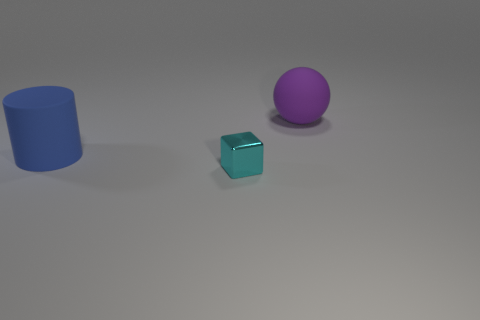Are there any other tiny objects that have the same shape as the blue object?
Offer a terse response. No. There is a blue thing that is the same size as the purple thing; what is its shape?
Keep it short and to the point. Cylinder. There is a big rubber object that is on the left side of the purple thing; what shape is it?
Offer a very short reply. Cylinder. Are there fewer big matte cylinders that are to the right of the blue cylinder than blue things that are behind the large purple rubber ball?
Offer a terse response. No. Does the purple ball have the same size as the object in front of the large blue object?
Your response must be concise. No. What number of matte things have the same size as the rubber ball?
Your response must be concise. 1. What is the color of the cylinder that is the same material as the large sphere?
Make the answer very short. Blue. Is the number of cyan metallic objects greater than the number of tiny gray metallic cylinders?
Your answer should be compact. Yes. Is the large blue cylinder made of the same material as the cyan block?
Your response must be concise. No. What is the shape of the big thing that is made of the same material as the purple sphere?
Provide a succinct answer. Cylinder. 